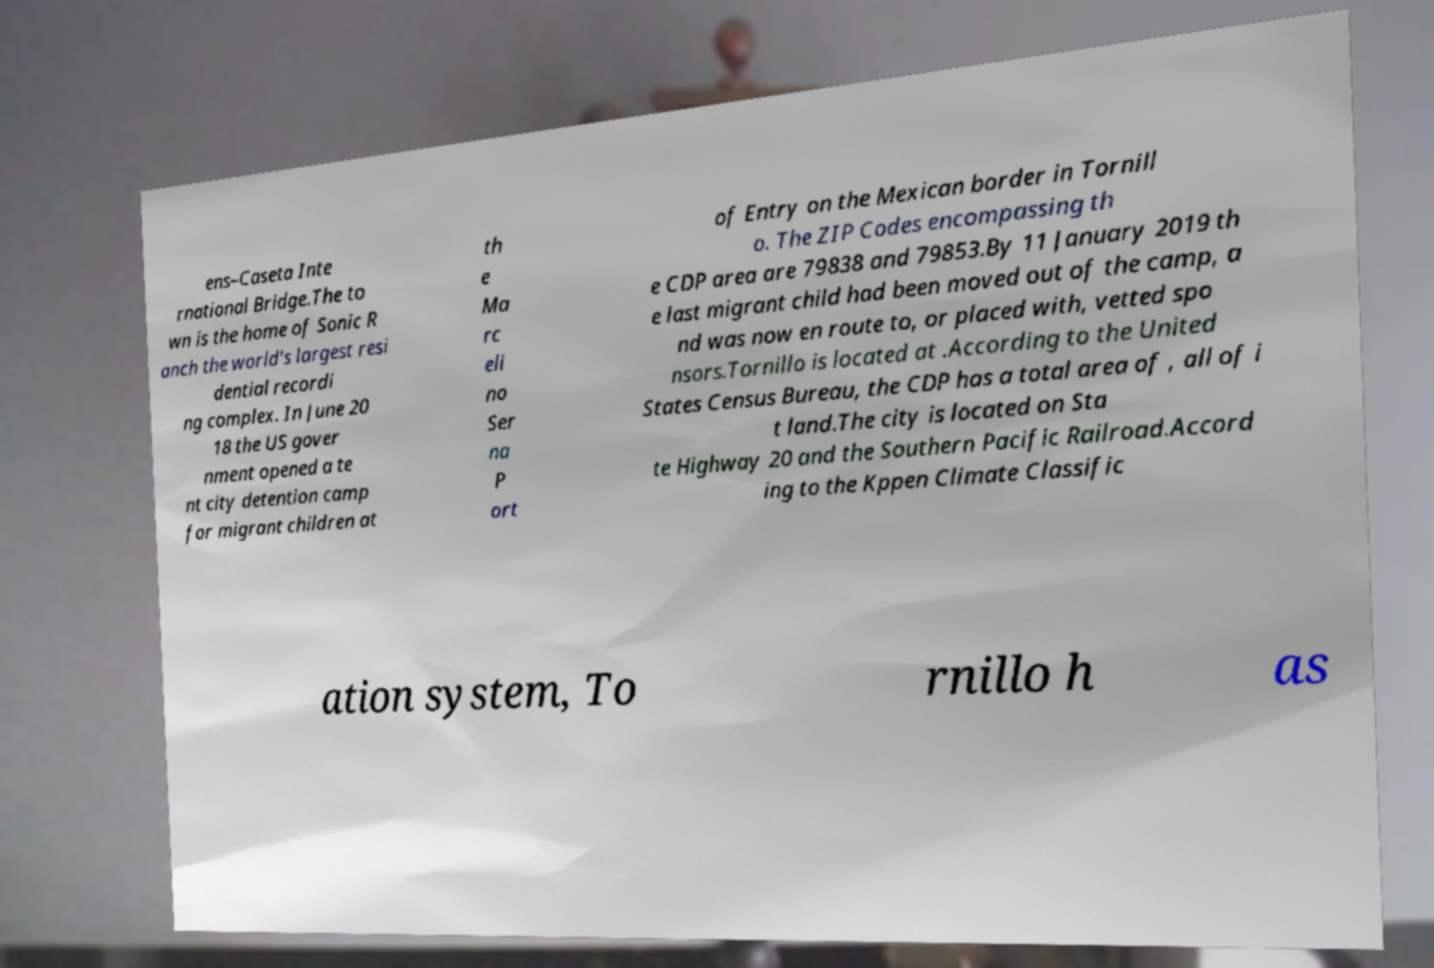I need the written content from this picture converted into text. Can you do that? ens–Caseta Inte rnational Bridge.The to wn is the home of Sonic R anch the world's largest resi dential recordi ng complex. In June 20 18 the US gover nment opened a te nt city detention camp for migrant children at th e Ma rc eli no Ser na P ort of Entry on the Mexican border in Tornill o. The ZIP Codes encompassing th e CDP area are 79838 and 79853.By 11 January 2019 th e last migrant child had been moved out of the camp, a nd was now en route to, or placed with, vetted spo nsors.Tornillo is located at .According to the United States Census Bureau, the CDP has a total area of , all of i t land.The city is located on Sta te Highway 20 and the Southern Pacific Railroad.Accord ing to the Kppen Climate Classific ation system, To rnillo h as 